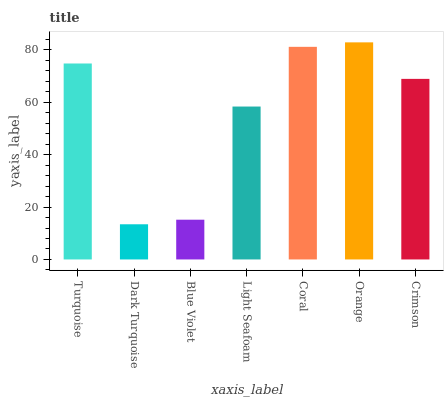Is Dark Turquoise the minimum?
Answer yes or no. Yes. Is Orange the maximum?
Answer yes or no. Yes. Is Blue Violet the minimum?
Answer yes or no. No. Is Blue Violet the maximum?
Answer yes or no. No. Is Blue Violet greater than Dark Turquoise?
Answer yes or no. Yes. Is Dark Turquoise less than Blue Violet?
Answer yes or no. Yes. Is Dark Turquoise greater than Blue Violet?
Answer yes or no. No. Is Blue Violet less than Dark Turquoise?
Answer yes or no. No. Is Crimson the high median?
Answer yes or no. Yes. Is Crimson the low median?
Answer yes or no. Yes. Is Blue Violet the high median?
Answer yes or no. No. Is Light Seafoam the low median?
Answer yes or no. No. 